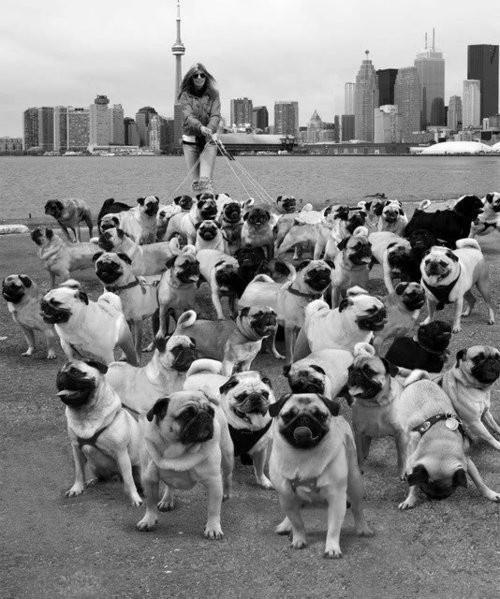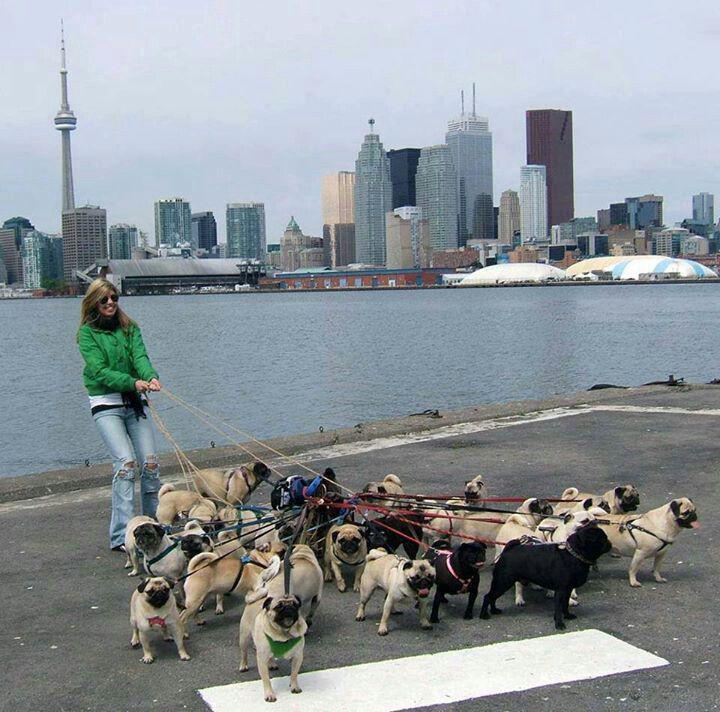The first image is the image on the left, the second image is the image on the right. For the images shown, is this caption "One image contains fewer than 3 pugs, and all pugs are on a leash." true? Answer yes or no. No. 